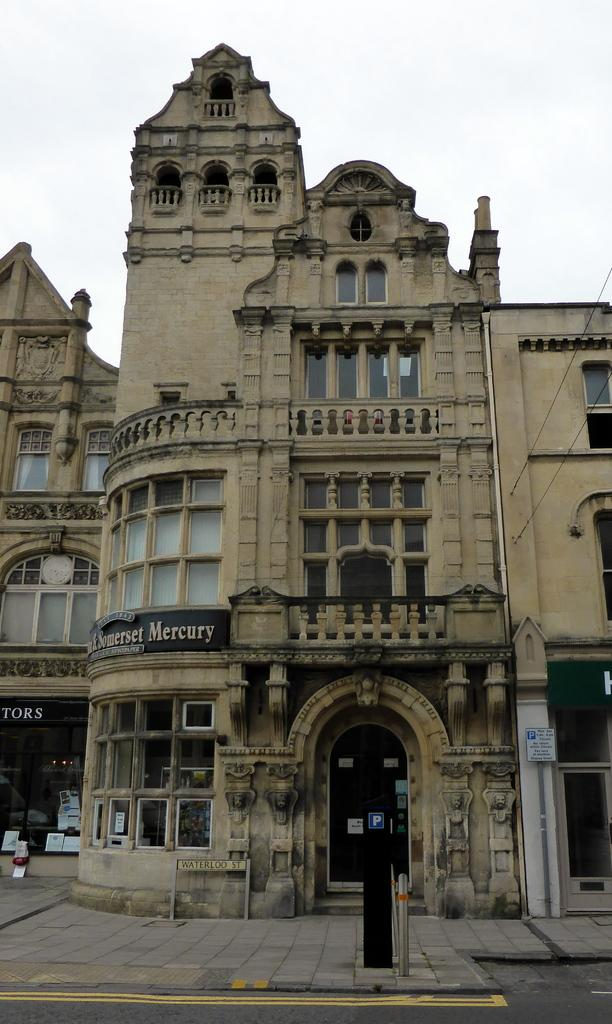What is the main feature of the image? There is a road in the image. What can be seen in the distance behind the road? There are buildings in the background of the image. Are there any details on the buildings? Yes, there is text written on the buildings. What is visible above the buildings and road? The sky is visible at the top of the image. What type of badge can be seen on the road in the image? There is no badge present on the road in the image. What color is the brick used to build the buildings in the image? The provided facts do not mention the color or material of the buildings, so we cannot determine the color of the brick. 